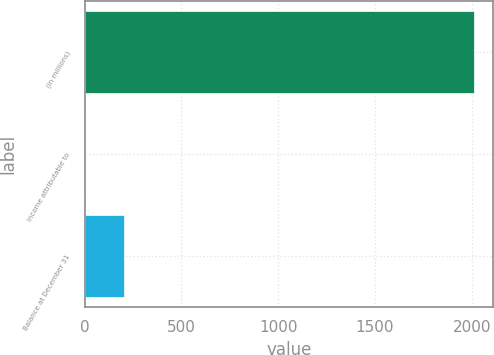Convert chart. <chart><loc_0><loc_0><loc_500><loc_500><bar_chart><fcel>(in millions)<fcel>income attributable to<fcel>Balance at December 31<nl><fcel>2010<fcel>0.6<fcel>201.54<nl></chart> 